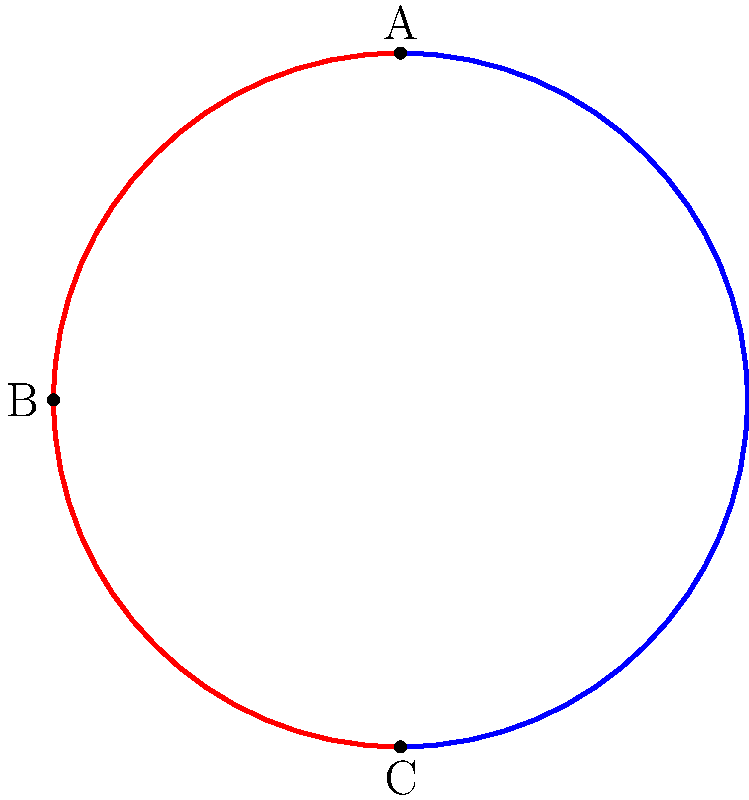In the diagram above, a non-Euclidean surface is represented by the blue arc, while a proposed wall design follows the red arc. If the straight-line distance between points A and C is 3 meters, what is the length of the curved wall (red arc) from B to C in meters, assuming the surface has constant positive curvature? To solve this problem, we'll follow these steps:

1) In a surface with constant positive curvature, we can model it as a sphere. The arc represents a quarter of a great circle on this sphere.

2) The straight-line distance between A and C (the diameter) is given as 3 meters. This means the radius of our sphere is 1.5 meters.

3) In a sphere, the ratio of an arc length to the full circumference is equal to the ratio of the central angle to 360°. Here, the central angle for the quarter circle is 90°.

4) The formula for the circumference of a great circle is $2\pi r$, where $r$ is the radius of the sphere.

5) Let's calculate:
   Circumference = $2\pi r = 2\pi(1.5) = 3\pi$ meters

6) The wall length (arc BC) is a quarter of this circumference:
   Wall length = $\frac{1}{4} * 3\pi = \frac{3\pi}{4}$ meters

Therefore, the length of the curved wall from B to C is $\frac{3\pi}{4}$ meters.
Answer: $\frac{3\pi}{4}$ meters 